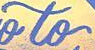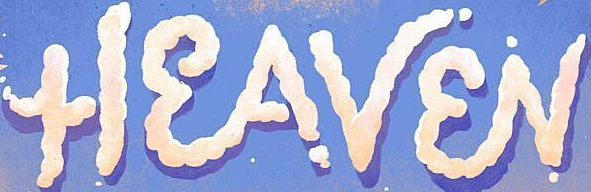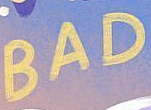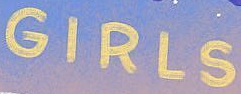Identify the words shown in these images in order, separated by a semicolon. to; HEAVEN; BAD; GIRLS 